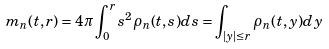<formula> <loc_0><loc_0><loc_500><loc_500>m _ { n } ( t , r ) = 4 \pi \int _ { 0 } ^ { r } s ^ { 2 } \rho _ { n } ( t , s ) d s = \int _ { | y | \leq r } \rho _ { n } ( t , y ) d y</formula> 